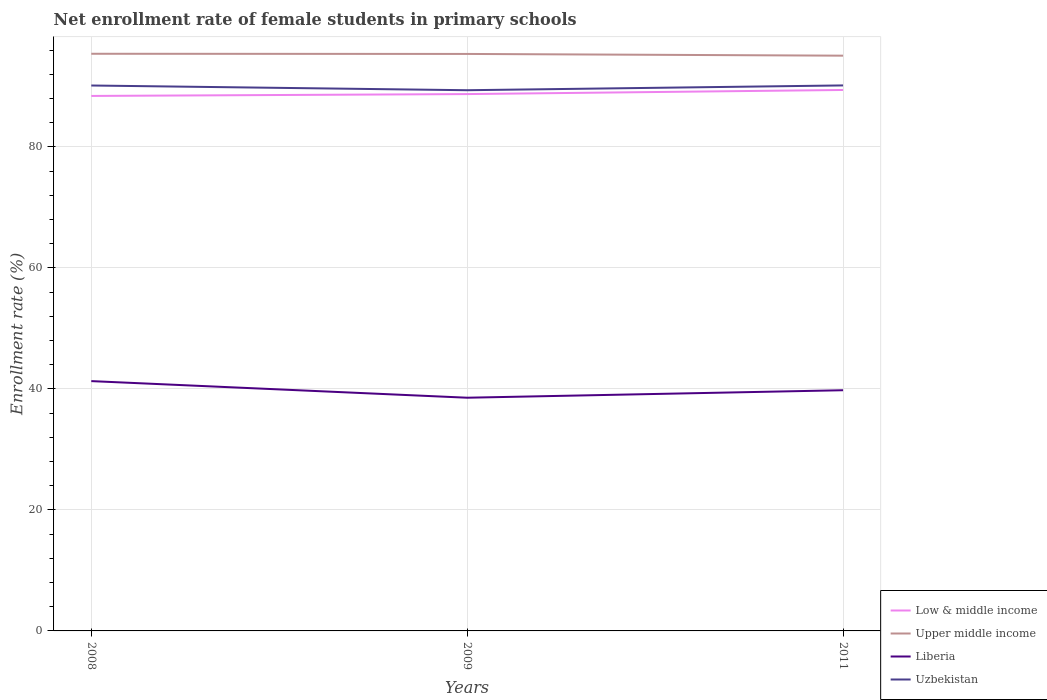Does the line corresponding to Upper middle income intersect with the line corresponding to Uzbekistan?
Provide a short and direct response. No. Is the number of lines equal to the number of legend labels?
Make the answer very short. Yes. Across all years, what is the maximum net enrollment rate of female students in primary schools in Low & middle income?
Keep it short and to the point. 88.43. In which year was the net enrollment rate of female students in primary schools in Low & middle income maximum?
Offer a terse response. 2008. What is the total net enrollment rate of female students in primary schools in Low & middle income in the graph?
Keep it short and to the point. -0.31. What is the difference between the highest and the second highest net enrollment rate of female students in primary schools in Liberia?
Ensure brevity in your answer.  2.75. How many lines are there?
Keep it short and to the point. 4. How many years are there in the graph?
Your answer should be compact. 3. What is the difference between two consecutive major ticks on the Y-axis?
Offer a terse response. 20. How are the legend labels stacked?
Offer a terse response. Vertical. What is the title of the graph?
Give a very brief answer. Net enrollment rate of female students in primary schools. Does "Bhutan" appear as one of the legend labels in the graph?
Your response must be concise. No. What is the label or title of the X-axis?
Give a very brief answer. Years. What is the label or title of the Y-axis?
Your answer should be very brief. Enrollment rate (%). What is the Enrollment rate (%) of Low & middle income in 2008?
Your answer should be compact. 88.43. What is the Enrollment rate (%) of Upper middle income in 2008?
Offer a terse response. 95.4. What is the Enrollment rate (%) of Liberia in 2008?
Provide a short and direct response. 41.29. What is the Enrollment rate (%) of Uzbekistan in 2008?
Offer a very short reply. 90.15. What is the Enrollment rate (%) of Low & middle income in 2009?
Offer a very short reply. 88.74. What is the Enrollment rate (%) in Upper middle income in 2009?
Offer a terse response. 95.37. What is the Enrollment rate (%) of Liberia in 2009?
Offer a very short reply. 38.55. What is the Enrollment rate (%) in Uzbekistan in 2009?
Provide a short and direct response. 89.37. What is the Enrollment rate (%) of Low & middle income in 2011?
Offer a terse response. 89.41. What is the Enrollment rate (%) in Upper middle income in 2011?
Provide a succinct answer. 95.08. What is the Enrollment rate (%) in Liberia in 2011?
Give a very brief answer. 39.78. What is the Enrollment rate (%) in Uzbekistan in 2011?
Your answer should be very brief. 90.17. Across all years, what is the maximum Enrollment rate (%) of Low & middle income?
Provide a succinct answer. 89.41. Across all years, what is the maximum Enrollment rate (%) of Upper middle income?
Your response must be concise. 95.4. Across all years, what is the maximum Enrollment rate (%) in Liberia?
Keep it short and to the point. 41.29. Across all years, what is the maximum Enrollment rate (%) in Uzbekistan?
Your answer should be compact. 90.17. Across all years, what is the minimum Enrollment rate (%) in Low & middle income?
Keep it short and to the point. 88.43. Across all years, what is the minimum Enrollment rate (%) of Upper middle income?
Make the answer very short. 95.08. Across all years, what is the minimum Enrollment rate (%) in Liberia?
Keep it short and to the point. 38.55. Across all years, what is the minimum Enrollment rate (%) of Uzbekistan?
Your answer should be very brief. 89.37. What is the total Enrollment rate (%) in Low & middle income in the graph?
Offer a very short reply. 266.58. What is the total Enrollment rate (%) of Upper middle income in the graph?
Your answer should be very brief. 285.85. What is the total Enrollment rate (%) of Liberia in the graph?
Give a very brief answer. 119.62. What is the total Enrollment rate (%) in Uzbekistan in the graph?
Your answer should be compact. 269.69. What is the difference between the Enrollment rate (%) of Low & middle income in 2008 and that in 2009?
Provide a short and direct response. -0.31. What is the difference between the Enrollment rate (%) of Upper middle income in 2008 and that in 2009?
Your answer should be compact. 0.03. What is the difference between the Enrollment rate (%) of Liberia in 2008 and that in 2009?
Provide a short and direct response. 2.75. What is the difference between the Enrollment rate (%) of Uzbekistan in 2008 and that in 2009?
Your response must be concise. 0.78. What is the difference between the Enrollment rate (%) in Low & middle income in 2008 and that in 2011?
Offer a terse response. -0.99. What is the difference between the Enrollment rate (%) of Upper middle income in 2008 and that in 2011?
Provide a short and direct response. 0.31. What is the difference between the Enrollment rate (%) in Liberia in 2008 and that in 2011?
Provide a short and direct response. 1.51. What is the difference between the Enrollment rate (%) of Uzbekistan in 2008 and that in 2011?
Give a very brief answer. -0.01. What is the difference between the Enrollment rate (%) in Low & middle income in 2009 and that in 2011?
Offer a very short reply. -0.68. What is the difference between the Enrollment rate (%) of Upper middle income in 2009 and that in 2011?
Your response must be concise. 0.29. What is the difference between the Enrollment rate (%) of Liberia in 2009 and that in 2011?
Your answer should be very brief. -1.24. What is the difference between the Enrollment rate (%) in Uzbekistan in 2009 and that in 2011?
Your answer should be very brief. -0.79. What is the difference between the Enrollment rate (%) of Low & middle income in 2008 and the Enrollment rate (%) of Upper middle income in 2009?
Provide a succinct answer. -6.94. What is the difference between the Enrollment rate (%) of Low & middle income in 2008 and the Enrollment rate (%) of Liberia in 2009?
Ensure brevity in your answer.  49.88. What is the difference between the Enrollment rate (%) in Low & middle income in 2008 and the Enrollment rate (%) in Uzbekistan in 2009?
Provide a short and direct response. -0.95. What is the difference between the Enrollment rate (%) in Upper middle income in 2008 and the Enrollment rate (%) in Liberia in 2009?
Offer a terse response. 56.85. What is the difference between the Enrollment rate (%) in Upper middle income in 2008 and the Enrollment rate (%) in Uzbekistan in 2009?
Give a very brief answer. 6.02. What is the difference between the Enrollment rate (%) in Liberia in 2008 and the Enrollment rate (%) in Uzbekistan in 2009?
Ensure brevity in your answer.  -48.08. What is the difference between the Enrollment rate (%) of Low & middle income in 2008 and the Enrollment rate (%) of Upper middle income in 2011?
Make the answer very short. -6.66. What is the difference between the Enrollment rate (%) of Low & middle income in 2008 and the Enrollment rate (%) of Liberia in 2011?
Provide a succinct answer. 48.64. What is the difference between the Enrollment rate (%) of Low & middle income in 2008 and the Enrollment rate (%) of Uzbekistan in 2011?
Your response must be concise. -1.74. What is the difference between the Enrollment rate (%) in Upper middle income in 2008 and the Enrollment rate (%) in Liberia in 2011?
Give a very brief answer. 55.61. What is the difference between the Enrollment rate (%) in Upper middle income in 2008 and the Enrollment rate (%) in Uzbekistan in 2011?
Provide a succinct answer. 5.23. What is the difference between the Enrollment rate (%) in Liberia in 2008 and the Enrollment rate (%) in Uzbekistan in 2011?
Make the answer very short. -48.88. What is the difference between the Enrollment rate (%) in Low & middle income in 2009 and the Enrollment rate (%) in Upper middle income in 2011?
Offer a very short reply. -6.35. What is the difference between the Enrollment rate (%) of Low & middle income in 2009 and the Enrollment rate (%) of Liberia in 2011?
Your answer should be compact. 48.95. What is the difference between the Enrollment rate (%) of Low & middle income in 2009 and the Enrollment rate (%) of Uzbekistan in 2011?
Ensure brevity in your answer.  -1.43. What is the difference between the Enrollment rate (%) in Upper middle income in 2009 and the Enrollment rate (%) in Liberia in 2011?
Your answer should be compact. 55.59. What is the difference between the Enrollment rate (%) of Upper middle income in 2009 and the Enrollment rate (%) of Uzbekistan in 2011?
Make the answer very short. 5.2. What is the difference between the Enrollment rate (%) in Liberia in 2009 and the Enrollment rate (%) in Uzbekistan in 2011?
Ensure brevity in your answer.  -51.62. What is the average Enrollment rate (%) in Low & middle income per year?
Your answer should be very brief. 88.86. What is the average Enrollment rate (%) in Upper middle income per year?
Keep it short and to the point. 95.28. What is the average Enrollment rate (%) in Liberia per year?
Provide a succinct answer. 39.87. What is the average Enrollment rate (%) in Uzbekistan per year?
Your answer should be compact. 89.9. In the year 2008, what is the difference between the Enrollment rate (%) in Low & middle income and Enrollment rate (%) in Upper middle income?
Give a very brief answer. -6.97. In the year 2008, what is the difference between the Enrollment rate (%) in Low & middle income and Enrollment rate (%) in Liberia?
Your answer should be very brief. 47.14. In the year 2008, what is the difference between the Enrollment rate (%) of Low & middle income and Enrollment rate (%) of Uzbekistan?
Provide a succinct answer. -1.73. In the year 2008, what is the difference between the Enrollment rate (%) in Upper middle income and Enrollment rate (%) in Liberia?
Provide a short and direct response. 54.11. In the year 2008, what is the difference between the Enrollment rate (%) of Upper middle income and Enrollment rate (%) of Uzbekistan?
Provide a succinct answer. 5.24. In the year 2008, what is the difference between the Enrollment rate (%) of Liberia and Enrollment rate (%) of Uzbekistan?
Keep it short and to the point. -48.86. In the year 2009, what is the difference between the Enrollment rate (%) of Low & middle income and Enrollment rate (%) of Upper middle income?
Provide a succinct answer. -6.63. In the year 2009, what is the difference between the Enrollment rate (%) in Low & middle income and Enrollment rate (%) in Liberia?
Your response must be concise. 50.19. In the year 2009, what is the difference between the Enrollment rate (%) in Low & middle income and Enrollment rate (%) in Uzbekistan?
Make the answer very short. -0.64. In the year 2009, what is the difference between the Enrollment rate (%) of Upper middle income and Enrollment rate (%) of Liberia?
Keep it short and to the point. 56.82. In the year 2009, what is the difference between the Enrollment rate (%) of Upper middle income and Enrollment rate (%) of Uzbekistan?
Your answer should be very brief. 6. In the year 2009, what is the difference between the Enrollment rate (%) of Liberia and Enrollment rate (%) of Uzbekistan?
Your answer should be compact. -50.83. In the year 2011, what is the difference between the Enrollment rate (%) in Low & middle income and Enrollment rate (%) in Upper middle income?
Offer a terse response. -5.67. In the year 2011, what is the difference between the Enrollment rate (%) in Low & middle income and Enrollment rate (%) in Liberia?
Ensure brevity in your answer.  49.63. In the year 2011, what is the difference between the Enrollment rate (%) of Low & middle income and Enrollment rate (%) of Uzbekistan?
Provide a short and direct response. -0.75. In the year 2011, what is the difference between the Enrollment rate (%) of Upper middle income and Enrollment rate (%) of Liberia?
Provide a succinct answer. 55.3. In the year 2011, what is the difference between the Enrollment rate (%) in Upper middle income and Enrollment rate (%) in Uzbekistan?
Provide a short and direct response. 4.92. In the year 2011, what is the difference between the Enrollment rate (%) of Liberia and Enrollment rate (%) of Uzbekistan?
Provide a succinct answer. -50.38. What is the ratio of the Enrollment rate (%) in Low & middle income in 2008 to that in 2009?
Ensure brevity in your answer.  1. What is the ratio of the Enrollment rate (%) of Upper middle income in 2008 to that in 2009?
Provide a succinct answer. 1. What is the ratio of the Enrollment rate (%) in Liberia in 2008 to that in 2009?
Give a very brief answer. 1.07. What is the ratio of the Enrollment rate (%) in Uzbekistan in 2008 to that in 2009?
Make the answer very short. 1.01. What is the ratio of the Enrollment rate (%) of Low & middle income in 2008 to that in 2011?
Offer a terse response. 0.99. What is the ratio of the Enrollment rate (%) in Liberia in 2008 to that in 2011?
Ensure brevity in your answer.  1.04. What is the ratio of the Enrollment rate (%) in Uzbekistan in 2008 to that in 2011?
Give a very brief answer. 1. What is the ratio of the Enrollment rate (%) in Low & middle income in 2009 to that in 2011?
Ensure brevity in your answer.  0.99. What is the ratio of the Enrollment rate (%) in Liberia in 2009 to that in 2011?
Your response must be concise. 0.97. What is the difference between the highest and the second highest Enrollment rate (%) in Low & middle income?
Make the answer very short. 0.68. What is the difference between the highest and the second highest Enrollment rate (%) in Upper middle income?
Keep it short and to the point. 0.03. What is the difference between the highest and the second highest Enrollment rate (%) of Liberia?
Your answer should be compact. 1.51. What is the difference between the highest and the second highest Enrollment rate (%) of Uzbekistan?
Offer a terse response. 0.01. What is the difference between the highest and the lowest Enrollment rate (%) of Low & middle income?
Give a very brief answer. 0.99. What is the difference between the highest and the lowest Enrollment rate (%) of Upper middle income?
Your response must be concise. 0.31. What is the difference between the highest and the lowest Enrollment rate (%) in Liberia?
Your answer should be very brief. 2.75. What is the difference between the highest and the lowest Enrollment rate (%) in Uzbekistan?
Your answer should be compact. 0.79. 